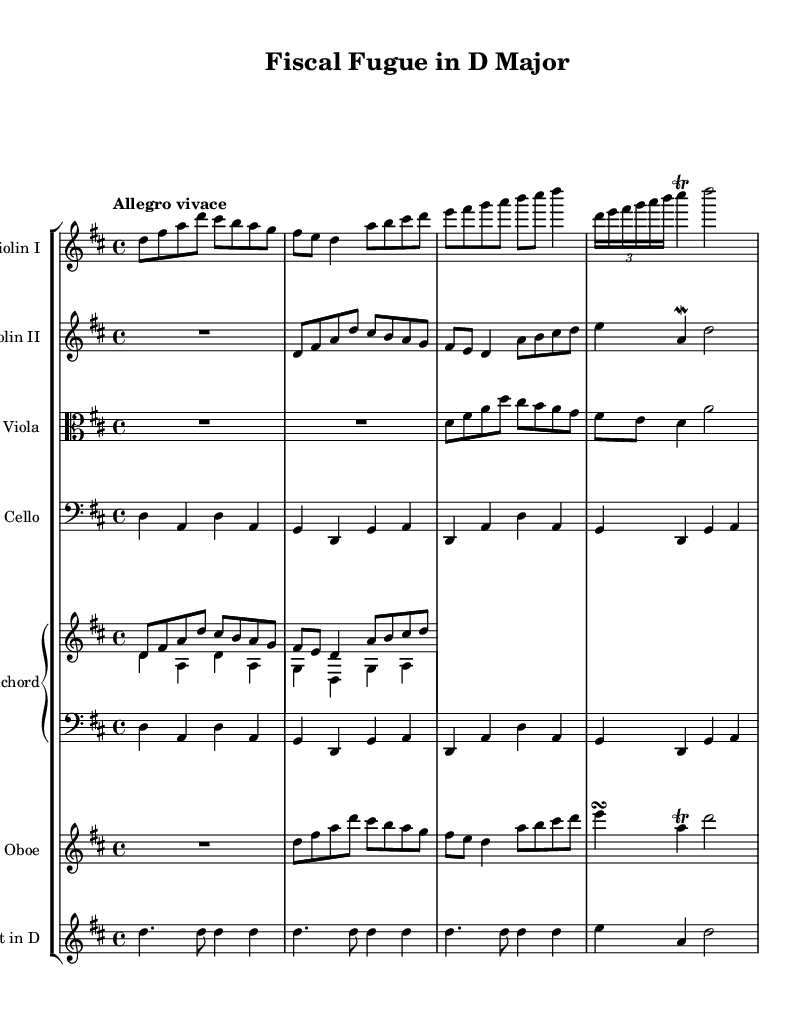What is the key signature of this music? The key signature is D major, which has two sharps: F# and C#.
Answer: D major What is the time signature of this piece? The time signature is 4/4, indicating four beats per measure.
Answer: 4/4 What is the tempo marking indicated in the score? The tempo marking is "Allegro vivace," suggesting a lively and fast pace.
Answer: Allegro vivace How many instruments are featured in this orchestral piece? There are six instruments: two violins, viola, cello, oboe, and trumpet.
Answer: Six What is the role of the harpsichord in this composition? The harpsichord provides harmonic support and rhythmic drive, typical for Baroque music.
Answer: Harmonic support Which instrument plays the melody in the first section? The melody is primarily played by the first violin.
Answer: Violin I How does the structure of this piece align with Baroque music characteristics? The piece features a clear structure with contrasting textures and a focus on polyphony, common in Baroque compositions.
Answer: Polyphony 